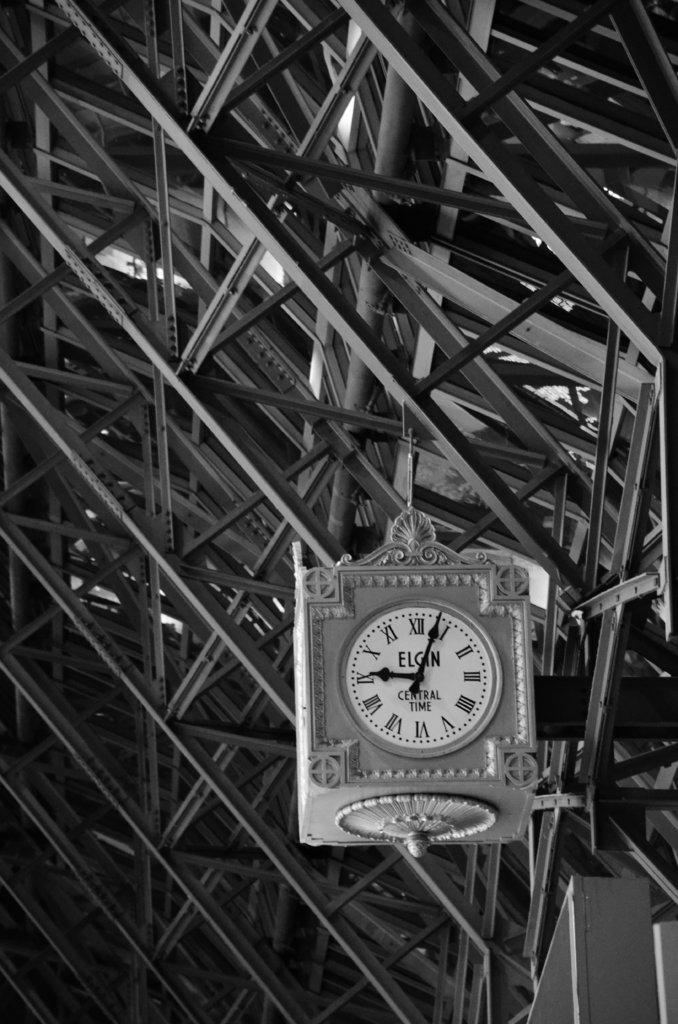What is the color scheme of the image? The image is black and white. What type of architectural feature can be seen in the picture? There are iron grills in the picture. What object is used for measuring time in the image? There is a clock in the picture. What type of foot design can be seen on the iron grills in the image? There is no foot design present on the iron grills in the image, as they are simply a structural feature. 